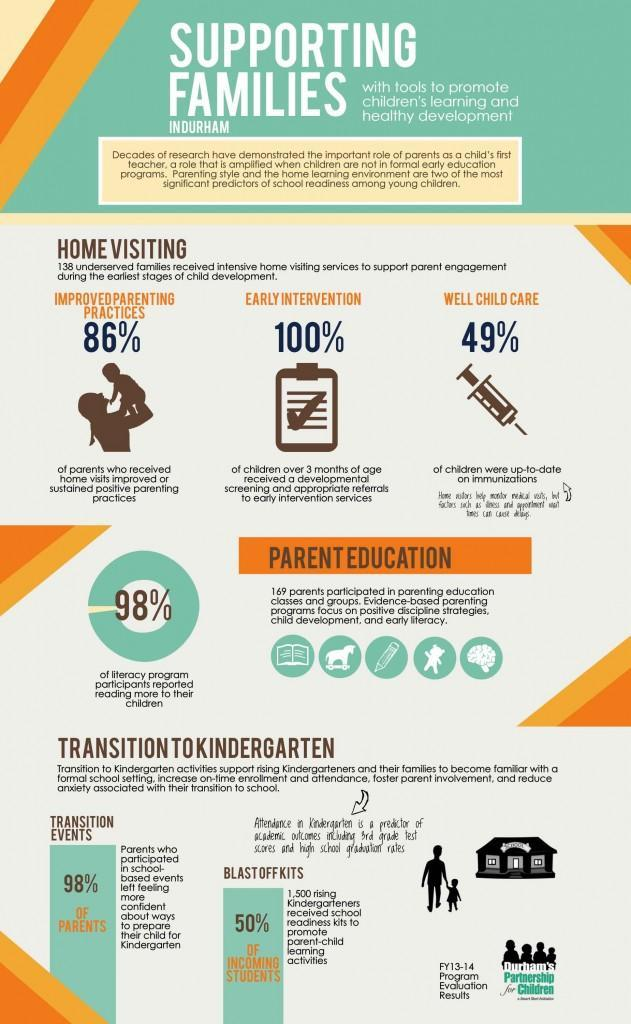What percentage of parents not improved their parenting practices?
Answer the question with a short phrase. 14% What percentage of children were not up-to-date on immunizations? 51% 